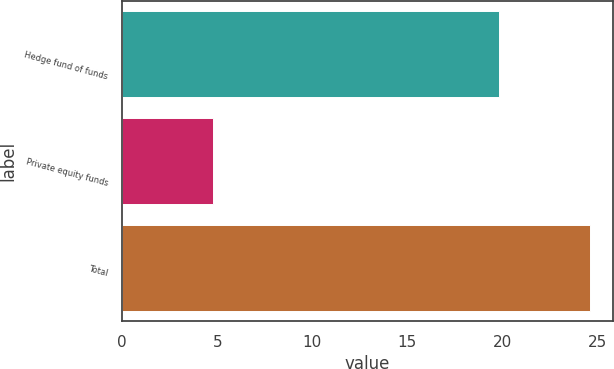Convert chart. <chart><loc_0><loc_0><loc_500><loc_500><bar_chart><fcel>Hedge fund of funds<fcel>Private equity funds<fcel>Total<nl><fcel>19.8<fcel>4.8<fcel>24.6<nl></chart> 